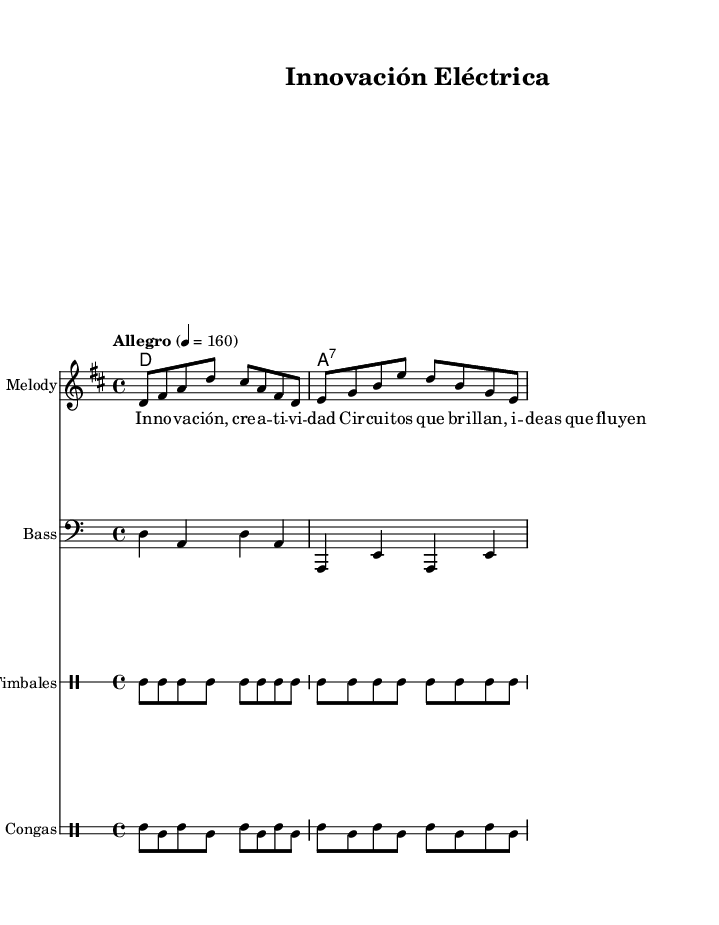What is the key signature of this music? The key signature is D major, indicated by two sharps (F# and C#) on the staff.
Answer: D major What is the time signature of this piece? The time signature is 4/4, which is represented by the fraction at the beginning of the score. This means there are four beats in each measure.
Answer: 4/4 What is the tempo marking for the piece? The tempo marking is "Allegro," which generally indicates a fast tempo, typically around 120-168 beats per minute. In this case, it is set to 160 beats per minute.
Answer: Allegro How many measures are in the melody section of the score? The melody section consists of 2 measures, as indicated by the lines and the notes grouped within them.
Answer: 2 measures What type of rhythm is predominantly used in the drums? The rhythm predominantly used in the drums is a syncopated pattern, characterized by the alternation between bass and snare in the timbales and congas parts, which is typical of salsa music.
Answer: Syncopated What is the main theme word expressed in the lyrics? The main theme word expressed in the lyrics is "Innovación," which translates to "Innovation" and highlights the central idea of creativity.
Answer: Innovación Which instruments are featured in the score besides the melody? The score features bass, timbales, and congas in addition to the melody, reflecting the vibrant instrumentation typical of salsa music.
Answer: Bass, timbales, congas 